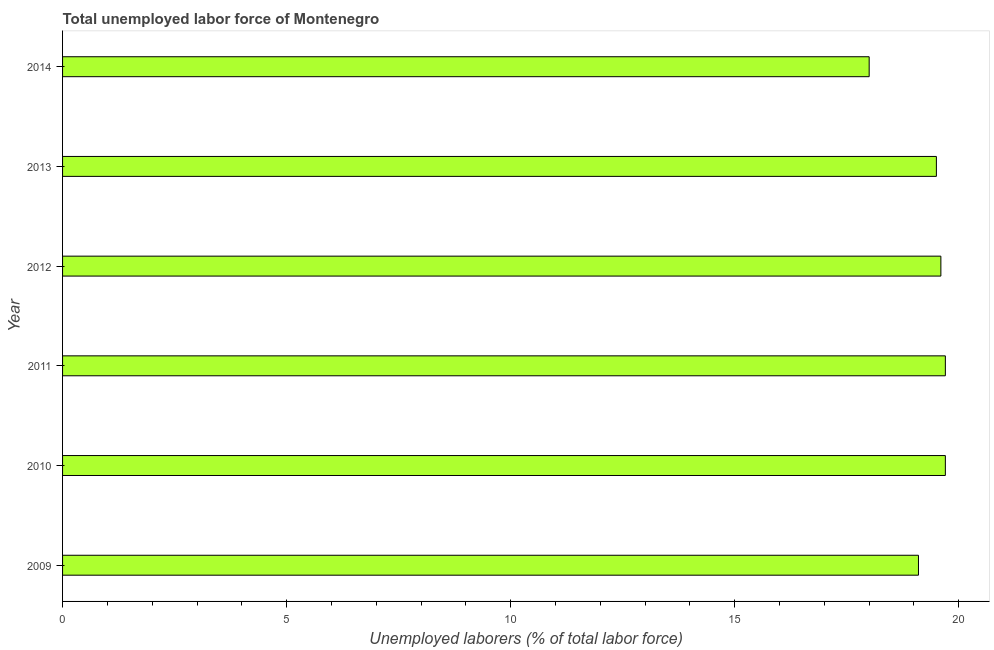Does the graph contain grids?
Offer a terse response. No. What is the title of the graph?
Provide a short and direct response. Total unemployed labor force of Montenegro. What is the label or title of the X-axis?
Offer a very short reply. Unemployed laborers (% of total labor force). What is the label or title of the Y-axis?
Offer a terse response. Year. What is the total unemployed labour force in 2012?
Make the answer very short. 19.6. Across all years, what is the maximum total unemployed labour force?
Your answer should be very brief. 19.7. Across all years, what is the minimum total unemployed labour force?
Offer a terse response. 18. In which year was the total unemployed labour force maximum?
Your answer should be compact. 2010. In which year was the total unemployed labour force minimum?
Offer a very short reply. 2014. What is the sum of the total unemployed labour force?
Keep it short and to the point. 115.6. What is the difference between the total unemployed labour force in 2010 and 2014?
Offer a very short reply. 1.7. What is the average total unemployed labour force per year?
Ensure brevity in your answer.  19.27. What is the median total unemployed labour force?
Your answer should be compact. 19.55. In how many years, is the total unemployed labour force greater than 4 %?
Offer a very short reply. 6. Do a majority of the years between 2010 and 2013 (inclusive) have total unemployed labour force greater than 16 %?
Your answer should be compact. Yes. What is the ratio of the total unemployed labour force in 2010 to that in 2013?
Ensure brevity in your answer.  1.01. Is the difference between the total unemployed labour force in 2009 and 2014 greater than the difference between any two years?
Make the answer very short. No. What is the difference between the highest and the lowest total unemployed labour force?
Offer a very short reply. 1.7. Are all the bars in the graph horizontal?
Offer a very short reply. Yes. How many years are there in the graph?
Give a very brief answer. 6. What is the difference between two consecutive major ticks on the X-axis?
Offer a terse response. 5. Are the values on the major ticks of X-axis written in scientific E-notation?
Keep it short and to the point. No. What is the Unemployed laborers (% of total labor force) in 2009?
Provide a short and direct response. 19.1. What is the Unemployed laborers (% of total labor force) in 2010?
Offer a terse response. 19.7. What is the Unemployed laborers (% of total labor force) of 2011?
Your answer should be very brief. 19.7. What is the Unemployed laborers (% of total labor force) of 2012?
Give a very brief answer. 19.6. What is the Unemployed laborers (% of total labor force) of 2014?
Offer a terse response. 18. What is the difference between the Unemployed laborers (% of total labor force) in 2009 and 2012?
Provide a succinct answer. -0.5. What is the difference between the Unemployed laborers (% of total labor force) in 2009 and 2014?
Keep it short and to the point. 1.1. What is the difference between the Unemployed laborers (% of total labor force) in 2010 and 2011?
Provide a short and direct response. 0. What is the difference between the Unemployed laborers (% of total labor force) in 2011 and 2014?
Provide a short and direct response. 1.7. What is the difference between the Unemployed laborers (% of total labor force) in 2012 and 2014?
Provide a short and direct response. 1.6. What is the difference between the Unemployed laborers (% of total labor force) in 2013 and 2014?
Provide a succinct answer. 1.5. What is the ratio of the Unemployed laborers (% of total labor force) in 2009 to that in 2013?
Ensure brevity in your answer.  0.98. What is the ratio of the Unemployed laborers (% of total labor force) in 2009 to that in 2014?
Your answer should be very brief. 1.06. What is the ratio of the Unemployed laborers (% of total labor force) in 2010 to that in 2014?
Offer a very short reply. 1.09. What is the ratio of the Unemployed laborers (% of total labor force) in 2011 to that in 2012?
Give a very brief answer. 1. What is the ratio of the Unemployed laborers (% of total labor force) in 2011 to that in 2013?
Keep it short and to the point. 1.01. What is the ratio of the Unemployed laborers (% of total labor force) in 2011 to that in 2014?
Your response must be concise. 1.09. What is the ratio of the Unemployed laborers (% of total labor force) in 2012 to that in 2013?
Provide a succinct answer. 1. What is the ratio of the Unemployed laborers (% of total labor force) in 2012 to that in 2014?
Ensure brevity in your answer.  1.09. What is the ratio of the Unemployed laborers (% of total labor force) in 2013 to that in 2014?
Make the answer very short. 1.08. 